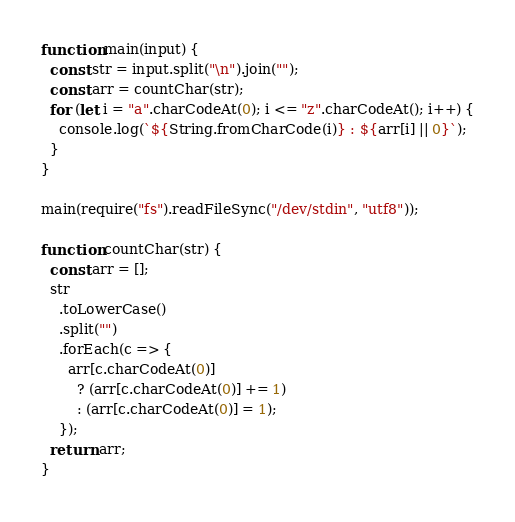<code> <loc_0><loc_0><loc_500><loc_500><_JavaScript_>function main(input) {
  const str = input.split("\n").join("");
  const arr = countChar(str);
  for (let i = "a".charCodeAt(0); i <= "z".charCodeAt(); i++) {
    console.log(`${String.fromCharCode(i)} : ${arr[i] || 0}`);
  }
}

main(require("fs").readFileSync("/dev/stdin", "utf8"));

function countChar(str) {
  const arr = [];
  str
    .toLowerCase()
    .split("")
    .forEach(c => {
      arr[c.charCodeAt(0)]
        ? (arr[c.charCodeAt(0)] += 1)
        : (arr[c.charCodeAt(0)] = 1);
    });
  return arr;
}

</code> 